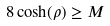Convert formula to latex. <formula><loc_0><loc_0><loc_500><loc_500>8 \cosh ( \rho ) \geq M</formula> 